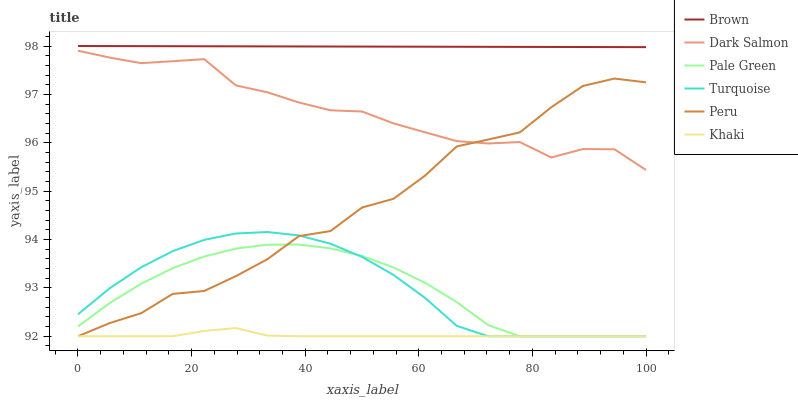Does Khaki have the minimum area under the curve?
Answer yes or no. Yes. Does Brown have the maximum area under the curve?
Answer yes or no. Yes. Does Turquoise have the minimum area under the curve?
Answer yes or no. No. Does Turquoise have the maximum area under the curve?
Answer yes or no. No. Is Brown the smoothest?
Answer yes or no. Yes. Is Peru the roughest?
Answer yes or no. Yes. Is Turquoise the smoothest?
Answer yes or no. No. Is Turquoise the roughest?
Answer yes or no. No. Does Dark Salmon have the lowest value?
Answer yes or no. No. Does Turquoise have the highest value?
Answer yes or no. No. Is Dark Salmon less than Brown?
Answer yes or no. Yes. Is Brown greater than Pale Green?
Answer yes or no. Yes. Does Dark Salmon intersect Brown?
Answer yes or no. No. 